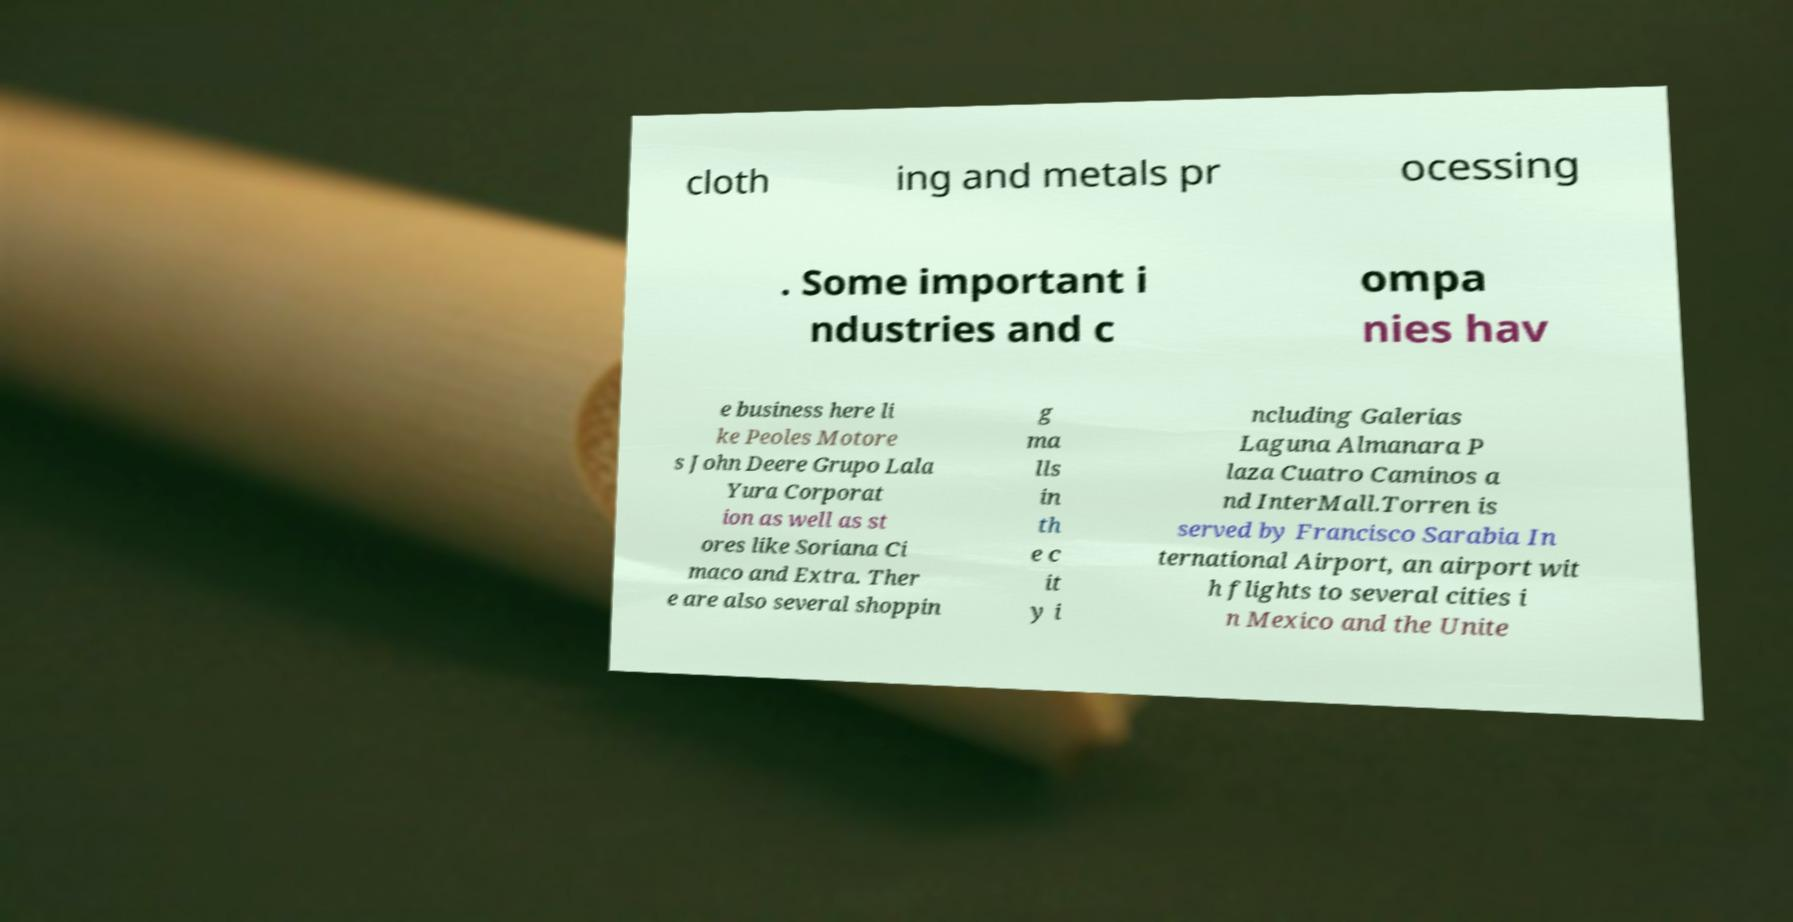I need the written content from this picture converted into text. Can you do that? cloth ing and metals pr ocessing . Some important i ndustries and c ompa nies hav e business here li ke Peoles Motore s John Deere Grupo Lala Yura Corporat ion as well as st ores like Soriana Ci maco and Extra. Ther e are also several shoppin g ma lls in th e c it y i ncluding Galerias Laguna Almanara P laza Cuatro Caminos a nd InterMall.Torren is served by Francisco Sarabia In ternational Airport, an airport wit h flights to several cities i n Mexico and the Unite 